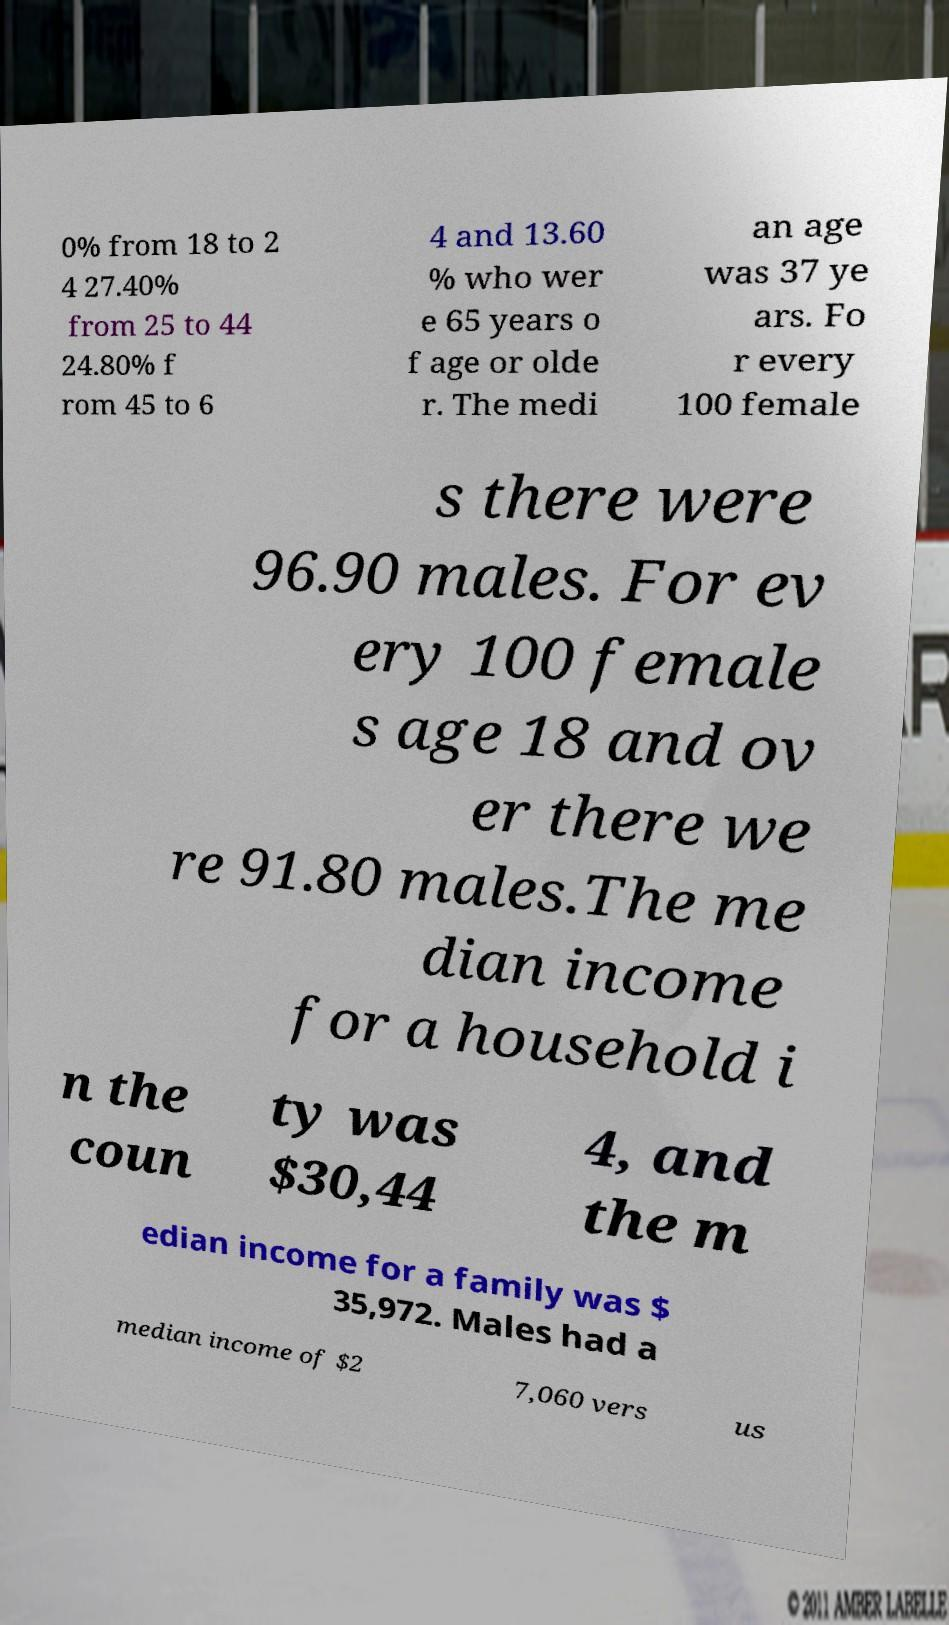There's text embedded in this image that I need extracted. Can you transcribe it verbatim? 0% from 18 to 2 4 27.40% from 25 to 44 24.80% f rom 45 to 6 4 and 13.60 % who wer e 65 years o f age or olde r. The medi an age was 37 ye ars. Fo r every 100 female s there were 96.90 males. For ev ery 100 female s age 18 and ov er there we re 91.80 males.The me dian income for a household i n the coun ty was $30,44 4, and the m edian income for a family was $ 35,972. Males had a median income of $2 7,060 vers us 